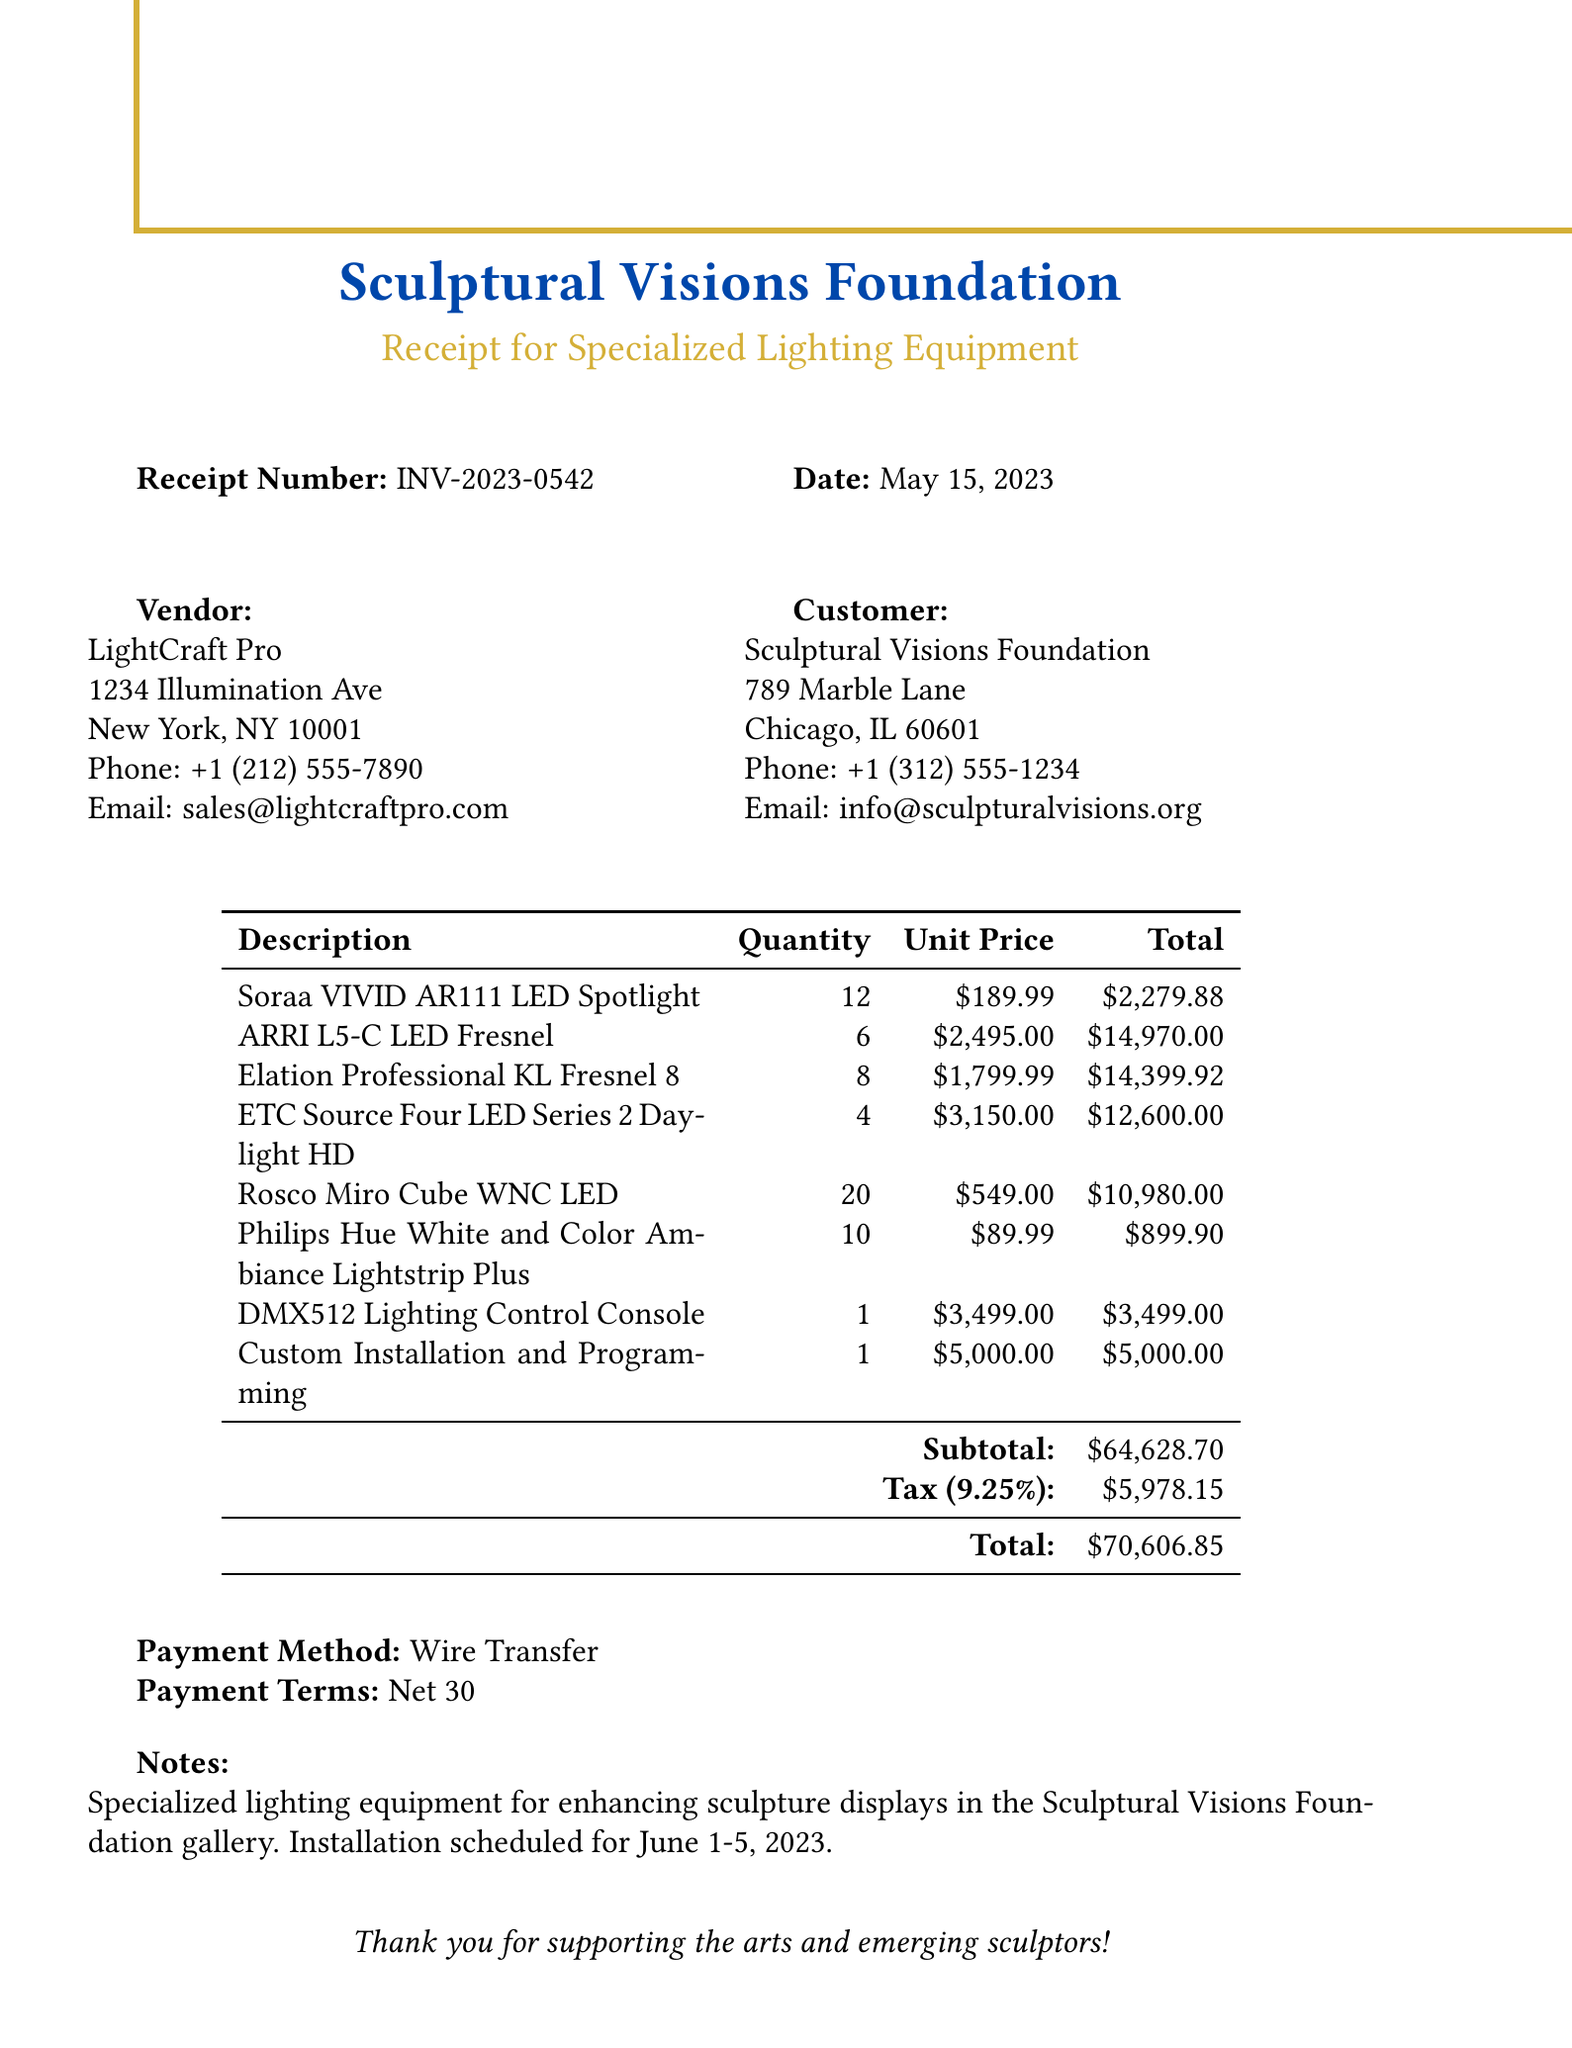What is the receipt number? The receipt number is provided in the document as a unique identifier for the transaction.
Answer: INV-2023-0542 What is the total amount due? The total amount is calculated as the subtotal plus the tax amount, which is shown in the document.
Answer: $70,606.85 Who is the vendor? The vendor's name appears prominently in the vendor section of the document.
Answer: LightCraft Pro What is the quantity of Soraa VIVID AR111 LED Spotlights purchased? The document lists the quantity of each item purchased, which is provided clearly.
Answer: 12 When is the installation scheduled? The notes section contains specific details about the installation schedule for the lighting equipment.
Answer: June 1-5, 2023 What is the tax rate applied? The tax rate is stated in the document and is essential for determining the tax amount.
Answer: 9.25% What payment method was used? The payment method is mentioned in the document, indicating how the transaction was completed.
Answer: Wire Transfer How many units of the DMX512 Lighting Control Console were purchased? The quantity of this specific item is listed in the itemized section of the document.
Answer: 1 What is the subtotal before tax? The subtotal is a key figure presented in the document that precedes any tax calculations.
Answer: $64,628.70 